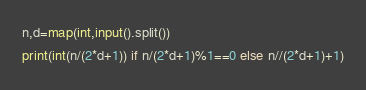<code> <loc_0><loc_0><loc_500><loc_500><_Python_>n,d=map(int,input().split())
print(int(n/(2*d+1)) if n/(2*d+1)%1==0 else n//(2*d+1)+1)</code> 